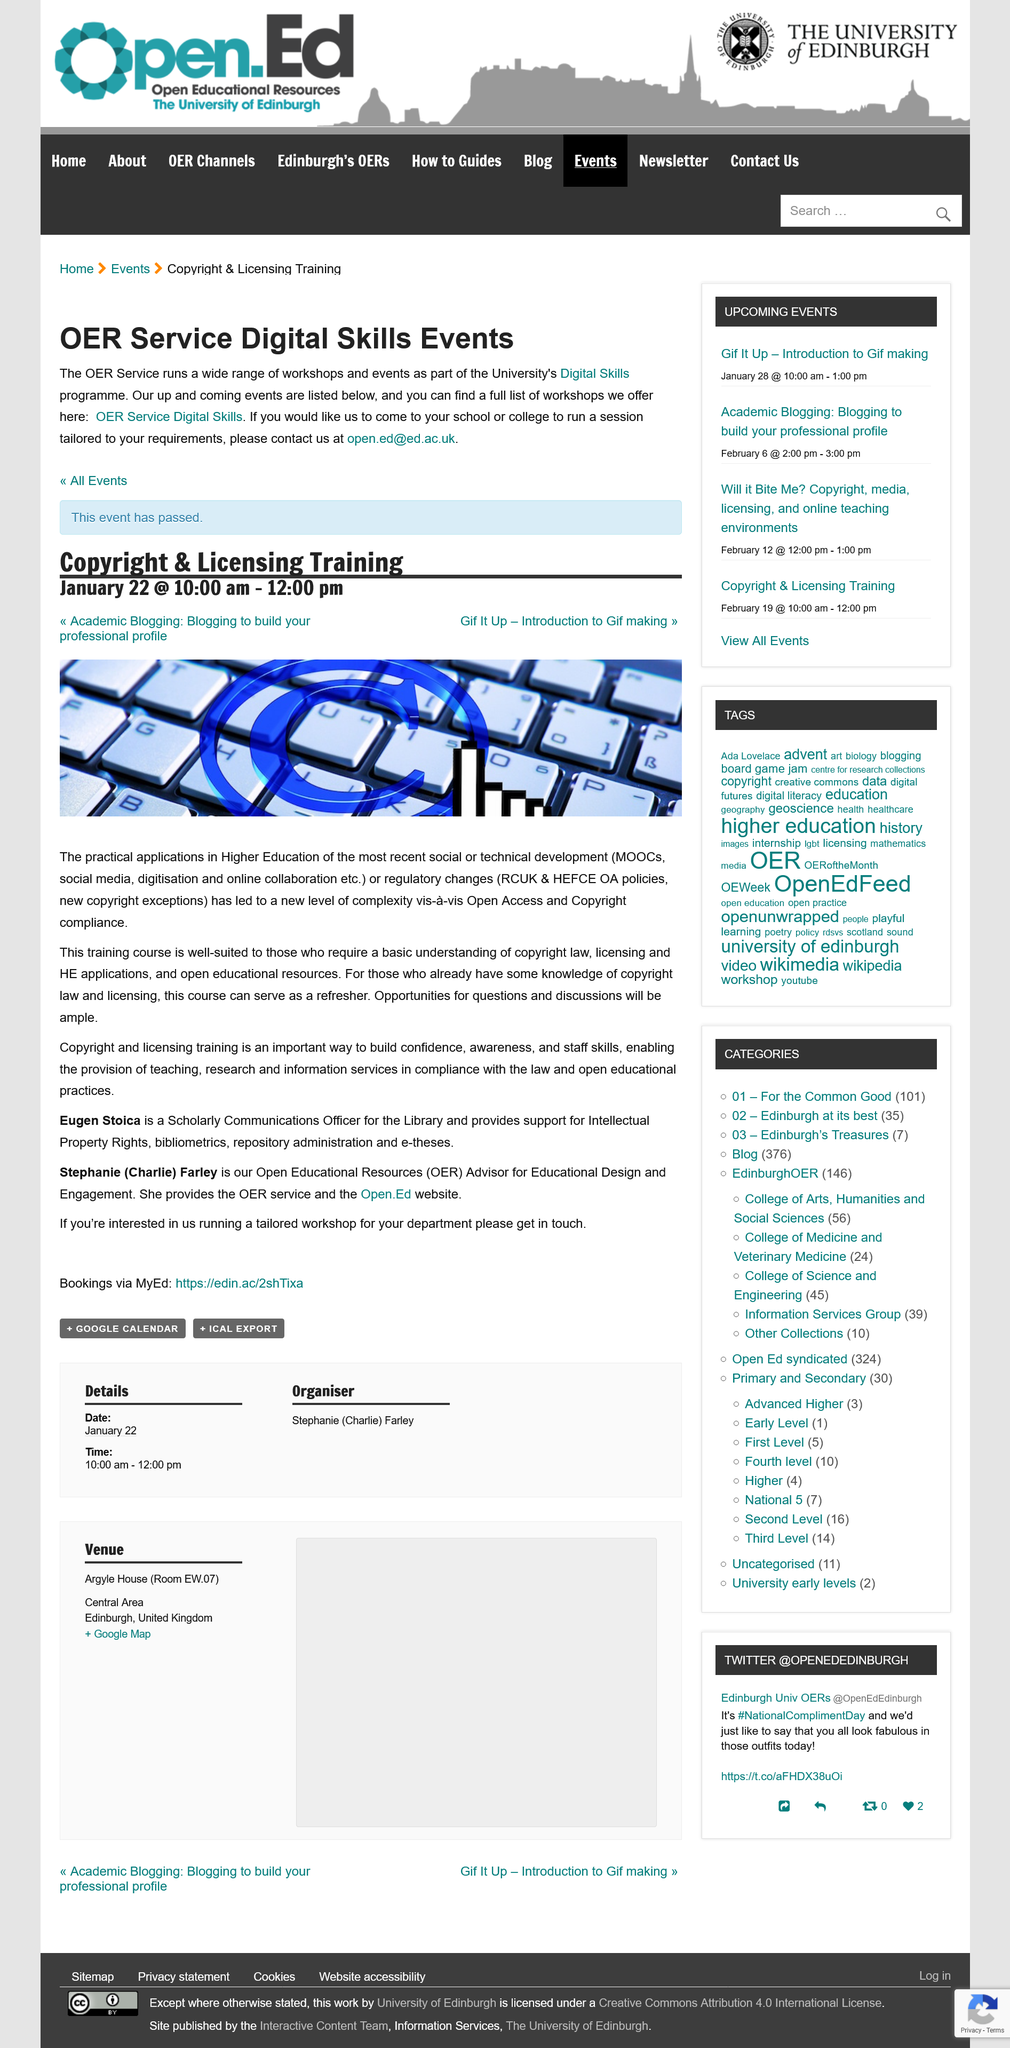Identify some key points in this picture. The Copyright and Licensing Training is to be held on January 22nd. Eugen Stoica and Stephanie Farler are mentioned in the article. The email address for the OER Service Digital Skills is [open.ed@ed.ac.uk](mailto:open.ed@ed.ac.uk). The OER Service, as part of the University's Digital Skills programme, runs a variety of workshops and events designed to enhance the digital proficiency of the University community. If you are interested in running a tailored workshop, you should contact us by using the link provided. 